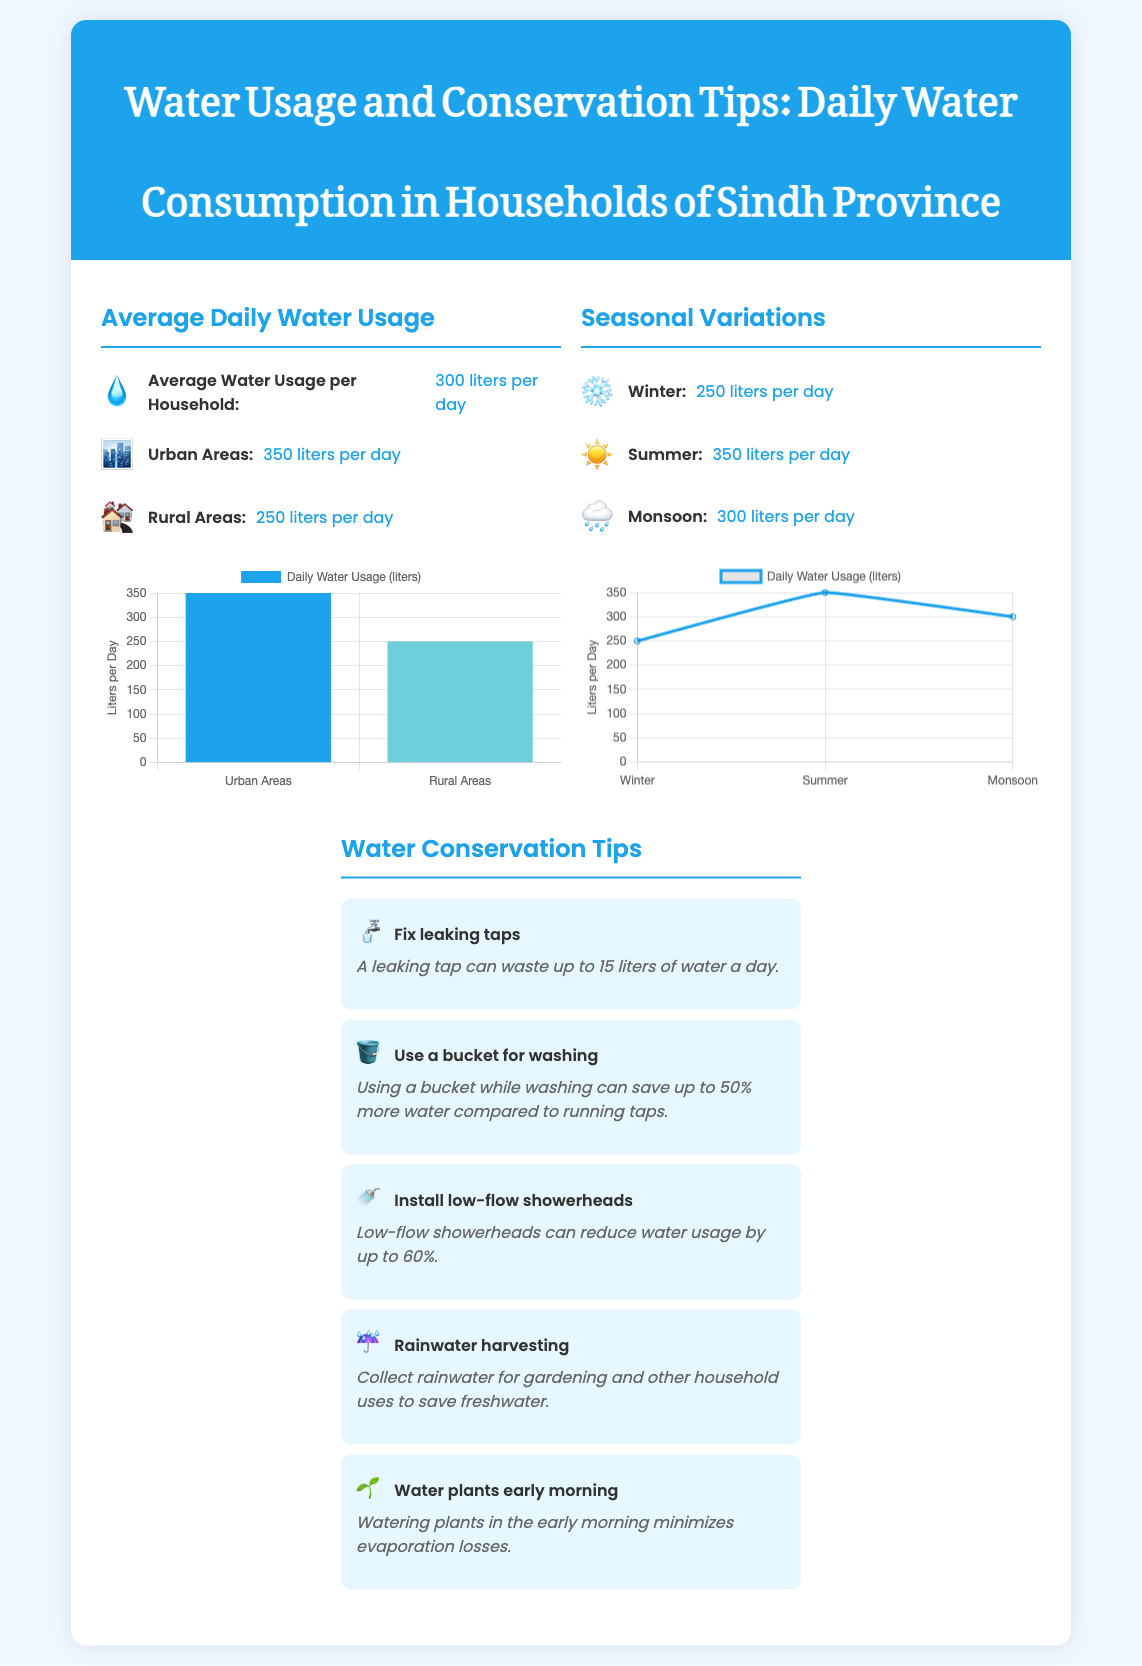what is the average daily water usage per household in Sindh Province? The average daily water usage per household in Sindh Province is stated as 300 liters per day.
Answer: 300 liters per day what is the average daily water usage in urban areas? The document specifies that the average daily water usage in urban areas is 350 liters per day.
Answer: 350 liters per day what is the average daily water usage in rural areas? The average daily water usage in rural areas is mentioned as 250 liters per day.
Answer: 250 liters per day how much water is used in winter? The document states that winter water usage is 250 liters per day.
Answer: 250 liters per day what is the water usage during summer? The water usage during summer is given as 350 liters per day.
Answer: 350 liters per day what is one of the tips for water conservation? One of the tips for water conservation mentioned is to fix leaking taps, which can waste up to 15 liters of water a day.
Answer: Fix leaking taps which season has the highest daily water usage? The highest daily water usage is during summer, at 350 liters per day.
Answer: Summer what percentage of water can be saved by using a bucket for washing? The document states that using a bucket can save up to 50% more water compared to running taps.
Answer: 50% what is the purpose of rainwater harvesting as mentioned in the tips? The purpose of rainwater harvesting is to collect rainwater for gardening and other household uses to save freshwater.
Answer: Save freshwater 